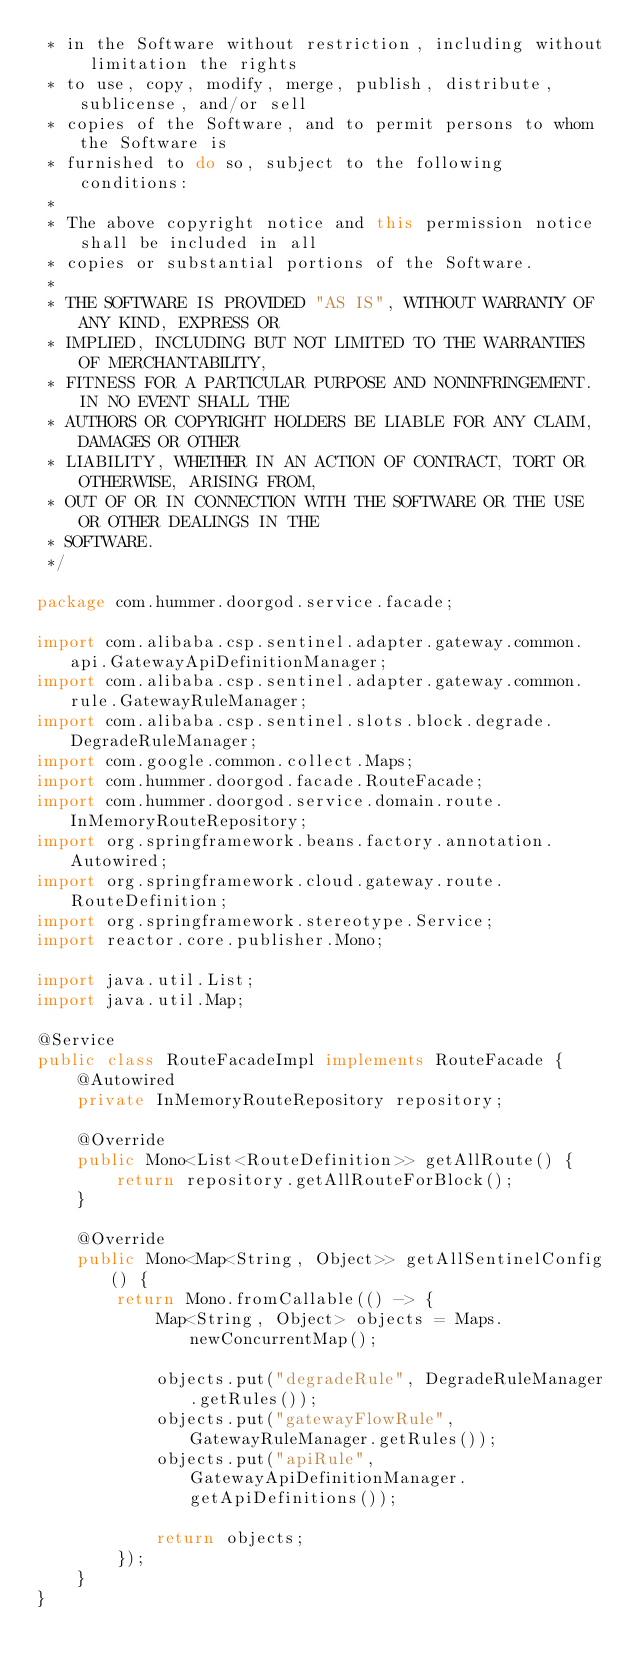<code> <loc_0><loc_0><loc_500><loc_500><_Java_> * in the Software without restriction, including without limitation the rights
 * to use, copy, modify, merge, publish, distribute, sublicense, and/or sell
 * copies of the Software, and to permit persons to whom the Software is
 * furnished to do so, subject to the following conditions:
 *
 * The above copyright notice and this permission notice shall be included in all
 * copies or substantial portions of the Software.
 *
 * THE SOFTWARE IS PROVIDED "AS IS", WITHOUT WARRANTY OF ANY KIND, EXPRESS OR
 * IMPLIED, INCLUDING BUT NOT LIMITED TO THE WARRANTIES OF MERCHANTABILITY,
 * FITNESS FOR A PARTICULAR PURPOSE AND NONINFRINGEMENT. IN NO EVENT SHALL THE
 * AUTHORS OR COPYRIGHT HOLDERS BE LIABLE FOR ANY CLAIM, DAMAGES OR OTHER
 * LIABILITY, WHETHER IN AN ACTION OF CONTRACT, TORT OR OTHERWISE, ARISING FROM,
 * OUT OF OR IN CONNECTION WITH THE SOFTWARE OR THE USE OR OTHER DEALINGS IN THE
 * SOFTWARE.
 */

package com.hummer.doorgod.service.facade;

import com.alibaba.csp.sentinel.adapter.gateway.common.api.GatewayApiDefinitionManager;
import com.alibaba.csp.sentinel.adapter.gateway.common.rule.GatewayRuleManager;
import com.alibaba.csp.sentinel.slots.block.degrade.DegradeRuleManager;
import com.google.common.collect.Maps;
import com.hummer.doorgod.facade.RouteFacade;
import com.hummer.doorgod.service.domain.route.InMemoryRouteRepository;
import org.springframework.beans.factory.annotation.Autowired;
import org.springframework.cloud.gateway.route.RouteDefinition;
import org.springframework.stereotype.Service;
import reactor.core.publisher.Mono;

import java.util.List;
import java.util.Map;

@Service
public class RouteFacadeImpl implements RouteFacade {
    @Autowired
    private InMemoryRouteRepository repository;

    @Override
    public Mono<List<RouteDefinition>> getAllRoute() {
        return repository.getAllRouteForBlock();
    }

    @Override
    public Mono<Map<String, Object>> getAllSentinelConfig() {
        return Mono.fromCallable(() -> {
            Map<String, Object> objects = Maps.newConcurrentMap();

            objects.put("degradeRule", DegradeRuleManager.getRules());
            objects.put("gatewayFlowRule", GatewayRuleManager.getRules());
            objects.put("apiRule", GatewayApiDefinitionManager.getApiDefinitions());

            return objects;
        });
    }
}
</code> 